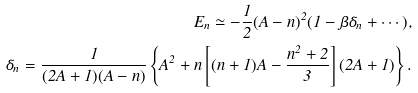Convert formula to latex. <formula><loc_0><loc_0><loc_500><loc_500>E _ { n } \simeq - \frac { 1 } { 2 } ( A - n ) ^ { 2 } ( 1 - \beta \delta _ { n } + \cdots ) , \\ \delta _ { n } = \frac { 1 } { ( 2 A + 1 ) ( A - n ) } \left \{ A ^ { 2 } + n \left [ ( n + 1 ) A - \frac { n ^ { 2 } + 2 } { 3 } \right ] ( 2 A + 1 ) \right \} .</formula> 